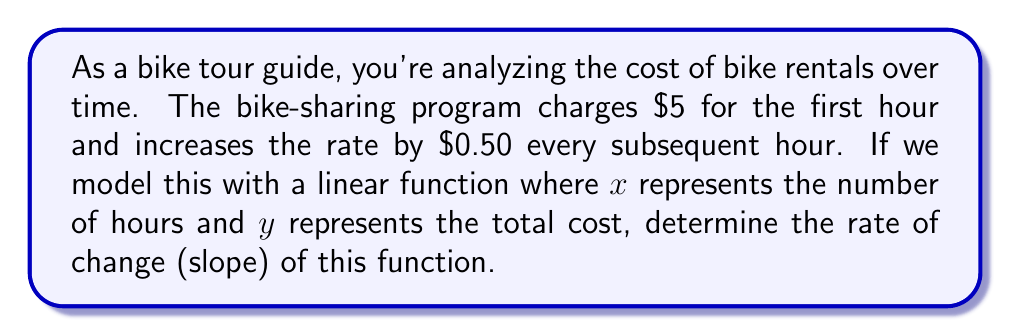Could you help me with this problem? To solve this problem, we need to understand the concept of rate of change and how to calculate it in a linear function.

1) First, let's identify two points on this function:
   - At $x = 1$ (first hour), $y = \$5$
   - At $x = 2$ (second hour), $y = \$5 + \$0.50 = \$5.50$

2) The rate of change (slope) in a linear function is calculated using the formula:

   $$m = \frac{y_2 - y_1}{x_2 - x_1}$$

   Where $(x_1, y_1)$ and $(x_2, y_2)$ are two points on the line.

3) Let's plug in our values:
   
   $$m = \frac{5.50 - 5}{2 - 1} = \frac{0.50}{1} = 0.50$$

4) This means that for every 1-hour increase in rental time, the cost increases by $\$0.50$.

5) We can verify this by checking a few more points:
   - At $x = 3$ (third hour), $y = \$5 + \$0.50 + \$0.50 = \$6$
   - At $x = 4$ (fourth hour), $y = \$5 + \$0.50 + \$0.50 + \$0.50 = \$6.50$

   We can see that the cost indeed increases by $\$0.50$ each hour.
Answer: The rate of change (slope) of the bike rental cost function is $\$0.50$ per hour. 